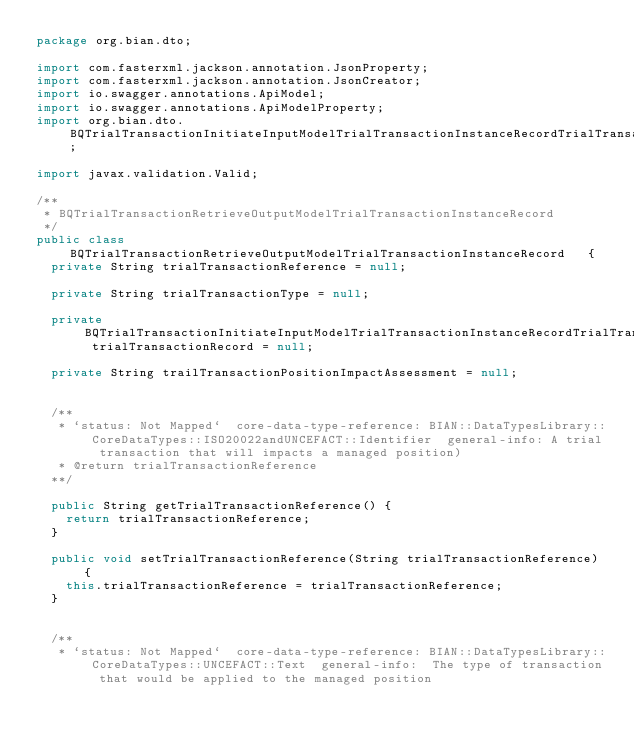<code> <loc_0><loc_0><loc_500><loc_500><_Java_>package org.bian.dto;

import com.fasterxml.jackson.annotation.JsonProperty;
import com.fasterxml.jackson.annotation.JsonCreator;
import io.swagger.annotations.ApiModel;
import io.swagger.annotations.ApiModelProperty;
import org.bian.dto.BQTrialTransactionInitiateInputModelTrialTransactionInstanceRecordTrialTransactionRecord;

import javax.validation.Valid;
  
/**
 * BQTrialTransactionRetrieveOutputModelTrialTransactionInstanceRecord
 */
public class BQTrialTransactionRetrieveOutputModelTrialTransactionInstanceRecord   {
  private String trialTransactionReference = null;

  private String trialTransactionType = null;

  private BQTrialTransactionInitiateInputModelTrialTransactionInstanceRecordTrialTransactionRecord trialTransactionRecord = null;

  private String trailTransactionPositionImpactAssessment = null;


  /**
   * `status: Not Mapped`  core-data-type-reference: BIAN::DataTypesLibrary::CoreDataTypes::ISO20022andUNCEFACT::Identifier  general-info: A trial transaction that will impacts a managed position) 
   * @return trialTransactionReference
  **/

  public String getTrialTransactionReference() {
    return trialTransactionReference;
  }

  public void setTrialTransactionReference(String trialTransactionReference) {
    this.trialTransactionReference = trialTransactionReference;
  }


  /**
   * `status: Not Mapped`  core-data-type-reference: BIAN::DataTypesLibrary::CoreDataTypes::UNCEFACT::Text  general-info:  The type of transaction that would be applied to the managed position </code> 